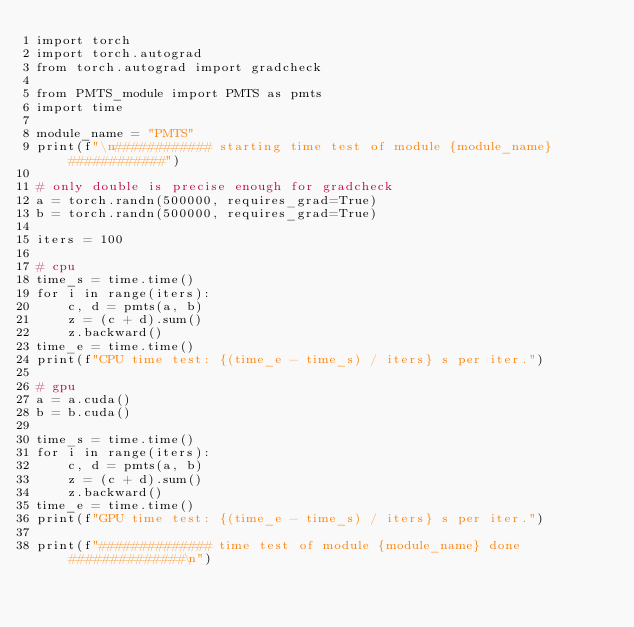<code> <loc_0><loc_0><loc_500><loc_500><_Python_>import torch
import torch.autograd
from torch.autograd import gradcheck

from PMTS_module import PMTS as pmts
import time

module_name = "PMTS"
print(f"\n############ starting time test of module {module_name} ############")

# only double is precise enough for gradcheck
a = torch.randn(500000, requires_grad=True)
b = torch.randn(500000, requires_grad=True)

iters = 100

# cpu
time_s = time.time()
for i in range(iters):
    c, d = pmts(a, b)
    z = (c + d).sum()
    z.backward()
time_e = time.time()
print(f"CPU time test: {(time_e - time_s) / iters} s per iter.")

# gpu
a = a.cuda()
b = b.cuda()

time_s = time.time()
for i in range(iters):
    c, d = pmts(a, b)
    z = (c + d).sum()
    z.backward()
time_e = time.time()
print(f"GPU time test: {(time_e - time_s) / iters} s per iter.")

print(f"############## time test of module {module_name} done ##############\n")
</code> 